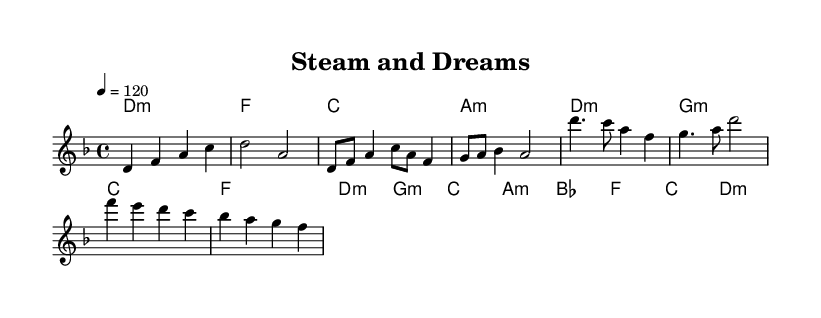What is the key signature of this music? The key signature is D minor, which has one flat (B♭). This can be determined from the global settings at the beginning of the code, where it specifies \key d \minor.
Answer: D minor What is the time signature of this piece? The time signature is 4/4, indicated in the global settings. This signifies there are four beats in each measure and a quarter note gets one beat.
Answer: 4/4 What is the tempo marking for this music? The tempo marking is 120 beats per minute, indicated by the instruction \tempo 4 = 120 in the global settings.
Answer: 120 What type of chords are used in the chorus? The chorus features minor chords, as seen from the chord progression which includes d:m, g:m, c, and a:m. Minor chords create a more somber and reflective quality, fitting the themes presented.
Answer: Minor chords How does the melody change from the verse to the chorus? The melody shifts from a more varied and descending pattern in the verse to a more structured and resolved pattern in the chorus, where it emphasizes higher notes such as d'4. This change represents a lift in emotional intensity.
Answer: More structured What theme does this piece explore within its music structure? The piece explores themes of industrialization and social change, reflected in the lyrics and the choice of harmonies and melody that suggest tension and resolution, mirroring the historical context of Victorian England.
Answer: Industrialization and social change 